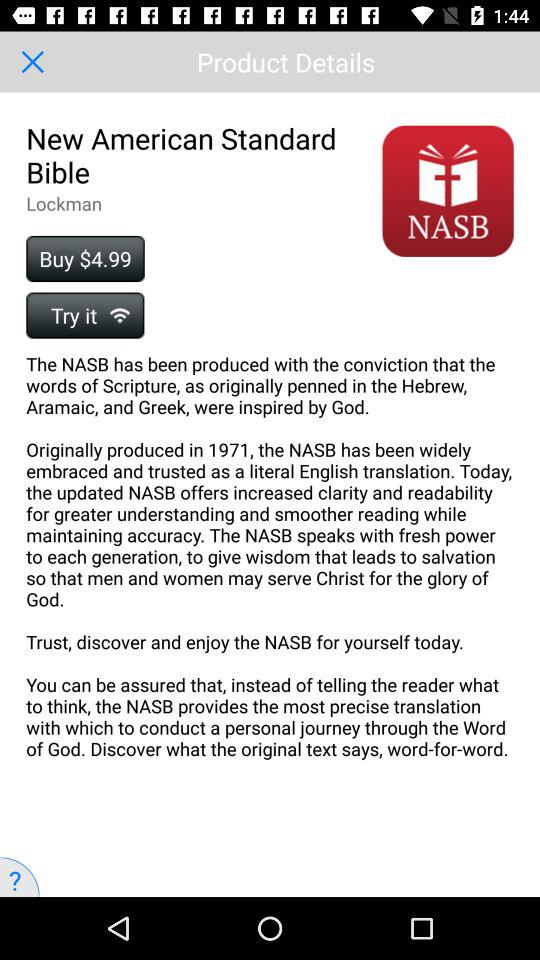How many different languages are mentioned in the description of the NASB?
Answer the question using a single word or phrase. 3 